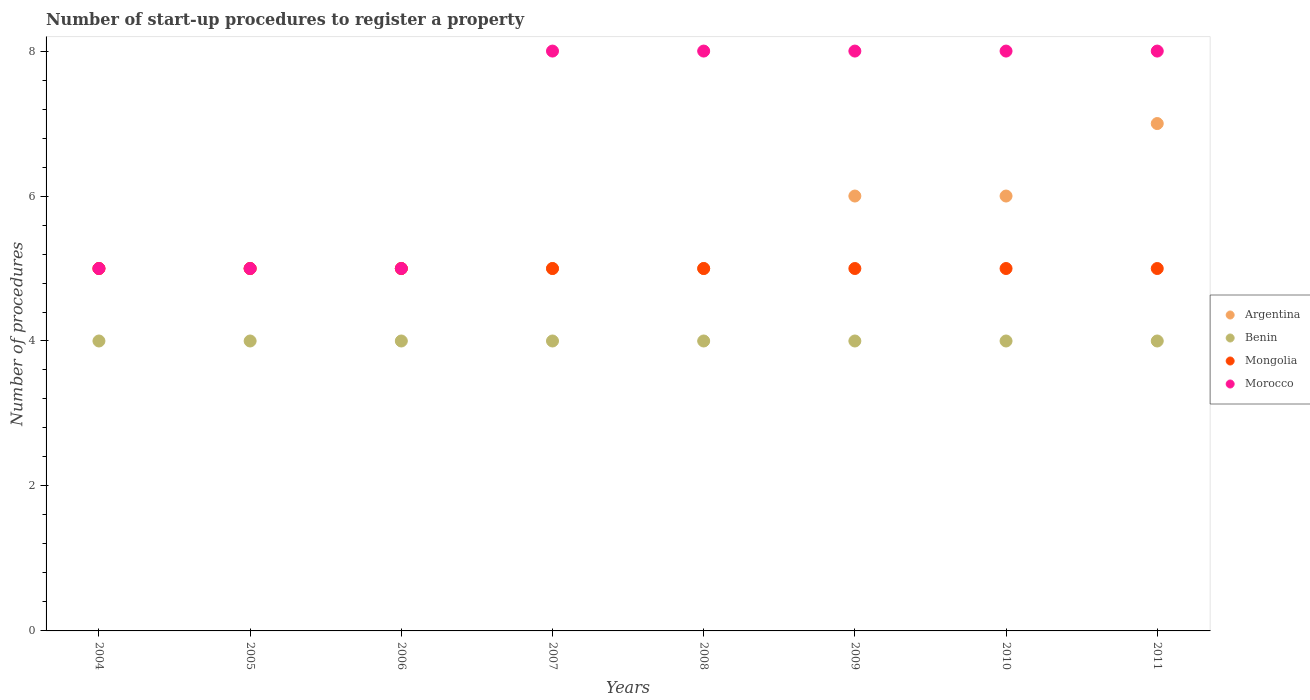Is the number of dotlines equal to the number of legend labels?
Offer a terse response. Yes. What is the number of procedures required to register a property in Morocco in 2006?
Offer a very short reply. 5. Across all years, what is the maximum number of procedures required to register a property in Benin?
Give a very brief answer. 4. Across all years, what is the minimum number of procedures required to register a property in Morocco?
Provide a short and direct response. 5. In which year was the number of procedures required to register a property in Morocco minimum?
Offer a very short reply. 2004. What is the total number of procedures required to register a property in Benin in the graph?
Ensure brevity in your answer.  32. What is the difference between the number of procedures required to register a property in Argentina in 2007 and that in 2009?
Your response must be concise. -1. What is the difference between the number of procedures required to register a property in Morocco in 2004 and the number of procedures required to register a property in Argentina in 2010?
Keep it short and to the point. -1. What is the average number of procedures required to register a property in Benin per year?
Offer a very short reply. 4. In the year 2007, what is the difference between the number of procedures required to register a property in Benin and number of procedures required to register a property in Argentina?
Offer a very short reply. -1. In how many years, is the number of procedures required to register a property in Argentina greater than 4.8?
Offer a terse response. 8. What is the ratio of the number of procedures required to register a property in Argentina in 2007 to that in 2010?
Give a very brief answer. 0.83. Is the number of procedures required to register a property in Mongolia in 2004 less than that in 2009?
Make the answer very short. No. In how many years, is the number of procedures required to register a property in Morocco greater than the average number of procedures required to register a property in Morocco taken over all years?
Keep it short and to the point. 5. Is the sum of the number of procedures required to register a property in Benin in 2009 and 2011 greater than the maximum number of procedures required to register a property in Argentina across all years?
Ensure brevity in your answer.  Yes. Is it the case that in every year, the sum of the number of procedures required to register a property in Morocco and number of procedures required to register a property in Argentina  is greater than the number of procedures required to register a property in Mongolia?
Ensure brevity in your answer.  Yes. Is the number of procedures required to register a property in Mongolia strictly less than the number of procedures required to register a property in Argentina over the years?
Provide a short and direct response. No. What is the difference between two consecutive major ticks on the Y-axis?
Your answer should be very brief. 2. Are the values on the major ticks of Y-axis written in scientific E-notation?
Ensure brevity in your answer.  No. Where does the legend appear in the graph?
Make the answer very short. Center right. What is the title of the graph?
Your answer should be compact. Number of start-up procedures to register a property. Does "Madagascar" appear as one of the legend labels in the graph?
Make the answer very short. No. What is the label or title of the Y-axis?
Keep it short and to the point. Number of procedures. What is the Number of procedures of Benin in 2004?
Your answer should be compact. 4. What is the Number of procedures of Benin in 2005?
Offer a very short reply. 4. What is the Number of procedures of Argentina in 2006?
Keep it short and to the point. 5. What is the Number of procedures in Benin in 2006?
Offer a very short reply. 4. What is the Number of procedures of Mongolia in 2006?
Provide a succinct answer. 5. What is the Number of procedures of Morocco in 2006?
Ensure brevity in your answer.  5. What is the Number of procedures of Mongolia in 2007?
Your response must be concise. 5. What is the Number of procedures of Mongolia in 2008?
Your answer should be very brief. 5. What is the Number of procedures in Benin in 2009?
Offer a very short reply. 4. What is the Number of procedures in Mongolia in 2009?
Your answer should be compact. 5. What is the Number of procedures of Morocco in 2009?
Offer a terse response. 8. What is the Number of procedures of Benin in 2010?
Your answer should be compact. 4. What is the Number of procedures in Benin in 2011?
Provide a succinct answer. 4. What is the Number of procedures in Mongolia in 2011?
Offer a terse response. 5. What is the Number of procedures of Morocco in 2011?
Offer a terse response. 8. Across all years, what is the maximum Number of procedures of Mongolia?
Your response must be concise. 5. Across all years, what is the maximum Number of procedures in Morocco?
Keep it short and to the point. 8. Across all years, what is the minimum Number of procedures in Benin?
Your answer should be very brief. 4. Across all years, what is the minimum Number of procedures in Mongolia?
Your response must be concise. 5. Across all years, what is the minimum Number of procedures in Morocco?
Keep it short and to the point. 5. What is the total Number of procedures of Benin in the graph?
Make the answer very short. 32. What is the difference between the Number of procedures of Argentina in 2004 and that in 2005?
Your response must be concise. 0. What is the difference between the Number of procedures in Benin in 2004 and that in 2007?
Your answer should be compact. 0. What is the difference between the Number of procedures in Mongolia in 2004 and that in 2007?
Offer a very short reply. 0. What is the difference between the Number of procedures of Morocco in 2004 and that in 2007?
Offer a terse response. -3. What is the difference between the Number of procedures of Argentina in 2004 and that in 2008?
Ensure brevity in your answer.  0. What is the difference between the Number of procedures in Mongolia in 2004 and that in 2008?
Make the answer very short. 0. What is the difference between the Number of procedures of Morocco in 2004 and that in 2008?
Your answer should be very brief. -3. What is the difference between the Number of procedures in Argentina in 2004 and that in 2009?
Your response must be concise. -1. What is the difference between the Number of procedures in Benin in 2004 and that in 2009?
Your response must be concise. 0. What is the difference between the Number of procedures in Mongolia in 2004 and that in 2010?
Your response must be concise. 0. What is the difference between the Number of procedures in Argentina in 2004 and that in 2011?
Your response must be concise. -2. What is the difference between the Number of procedures in Morocco in 2004 and that in 2011?
Make the answer very short. -3. What is the difference between the Number of procedures of Argentina in 2005 and that in 2006?
Provide a succinct answer. 0. What is the difference between the Number of procedures of Benin in 2005 and that in 2007?
Offer a terse response. 0. What is the difference between the Number of procedures of Morocco in 2005 and that in 2007?
Your response must be concise. -3. What is the difference between the Number of procedures in Argentina in 2005 and that in 2008?
Offer a very short reply. 0. What is the difference between the Number of procedures in Argentina in 2005 and that in 2009?
Your response must be concise. -1. What is the difference between the Number of procedures of Benin in 2005 and that in 2010?
Your response must be concise. 0. What is the difference between the Number of procedures in Mongolia in 2005 and that in 2010?
Keep it short and to the point. 0. What is the difference between the Number of procedures in Morocco in 2005 and that in 2010?
Your answer should be very brief. -3. What is the difference between the Number of procedures of Benin in 2005 and that in 2011?
Give a very brief answer. 0. What is the difference between the Number of procedures of Morocco in 2005 and that in 2011?
Make the answer very short. -3. What is the difference between the Number of procedures in Benin in 2006 and that in 2007?
Give a very brief answer. 0. What is the difference between the Number of procedures of Mongolia in 2006 and that in 2007?
Give a very brief answer. 0. What is the difference between the Number of procedures in Morocco in 2006 and that in 2007?
Offer a terse response. -3. What is the difference between the Number of procedures of Benin in 2006 and that in 2008?
Your answer should be compact. 0. What is the difference between the Number of procedures in Mongolia in 2006 and that in 2008?
Ensure brevity in your answer.  0. What is the difference between the Number of procedures of Morocco in 2006 and that in 2009?
Ensure brevity in your answer.  -3. What is the difference between the Number of procedures in Argentina in 2006 and that in 2010?
Provide a short and direct response. -1. What is the difference between the Number of procedures of Benin in 2006 and that in 2010?
Your answer should be compact. 0. What is the difference between the Number of procedures of Mongolia in 2006 and that in 2010?
Your answer should be compact. 0. What is the difference between the Number of procedures of Benin in 2006 and that in 2011?
Provide a succinct answer. 0. What is the difference between the Number of procedures of Mongolia in 2006 and that in 2011?
Offer a terse response. 0. What is the difference between the Number of procedures in Argentina in 2007 and that in 2008?
Provide a short and direct response. 0. What is the difference between the Number of procedures in Benin in 2007 and that in 2008?
Make the answer very short. 0. What is the difference between the Number of procedures of Benin in 2007 and that in 2009?
Your answer should be compact. 0. What is the difference between the Number of procedures of Mongolia in 2007 and that in 2009?
Offer a terse response. 0. What is the difference between the Number of procedures of Argentina in 2007 and that in 2010?
Your response must be concise. -1. What is the difference between the Number of procedures of Mongolia in 2007 and that in 2010?
Keep it short and to the point. 0. What is the difference between the Number of procedures of Morocco in 2007 and that in 2010?
Your answer should be compact. 0. What is the difference between the Number of procedures in Argentina in 2007 and that in 2011?
Offer a very short reply. -2. What is the difference between the Number of procedures in Benin in 2007 and that in 2011?
Provide a short and direct response. 0. What is the difference between the Number of procedures in Argentina in 2008 and that in 2009?
Provide a short and direct response. -1. What is the difference between the Number of procedures of Benin in 2008 and that in 2010?
Keep it short and to the point. 0. What is the difference between the Number of procedures of Mongolia in 2008 and that in 2010?
Ensure brevity in your answer.  0. What is the difference between the Number of procedures in Benin in 2008 and that in 2011?
Give a very brief answer. 0. What is the difference between the Number of procedures of Mongolia in 2008 and that in 2011?
Give a very brief answer. 0. What is the difference between the Number of procedures of Argentina in 2009 and that in 2010?
Your answer should be compact. 0. What is the difference between the Number of procedures in Morocco in 2009 and that in 2010?
Your answer should be very brief. 0. What is the difference between the Number of procedures in Argentina in 2009 and that in 2011?
Provide a short and direct response. -1. What is the difference between the Number of procedures of Mongolia in 2009 and that in 2011?
Ensure brevity in your answer.  0. What is the difference between the Number of procedures of Benin in 2010 and that in 2011?
Provide a short and direct response. 0. What is the difference between the Number of procedures in Mongolia in 2010 and that in 2011?
Your response must be concise. 0. What is the difference between the Number of procedures in Morocco in 2010 and that in 2011?
Your answer should be very brief. 0. What is the difference between the Number of procedures of Benin in 2004 and the Number of procedures of Mongolia in 2005?
Ensure brevity in your answer.  -1. What is the difference between the Number of procedures of Mongolia in 2004 and the Number of procedures of Morocco in 2005?
Your response must be concise. 0. What is the difference between the Number of procedures in Argentina in 2004 and the Number of procedures in Benin in 2006?
Provide a succinct answer. 1. What is the difference between the Number of procedures in Argentina in 2004 and the Number of procedures in Morocco in 2006?
Provide a succinct answer. 0. What is the difference between the Number of procedures in Mongolia in 2004 and the Number of procedures in Morocco in 2006?
Offer a very short reply. 0. What is the difference between the Number of procedures in Argentina in 2004 and the Number of procedures in Benin in 2007?
Give a very brief answer. 1. What is the difference between the Number of procedures in Argentina in 2004 and the Number of procedures in Morocco in 2007?
Provide a succinct answer. -3. What is the difference between the Number of procedures in Mongolia in 2004 and the Number of procedures in Morocco in 2007?
Your response must be concise. -3. What is the difference between the Number of procedures of Argentina in 2004 and the Number of procedures of Benin in 2008?
Offer a terse response. 1. What is the difference between the Number of procedures in Argentina in 2004 and the Number of procedures in Mongolia in 2008?
Your answer should be very brief. 0. What is the difference between the Number of procedures in Benin in 2004 and the Number of procedures in Mongolia in 2008?
Your answer should be very brief. -1. What is the difference between the Number of procedures in Mongolia in 2004 and the Number of procedures in Morocco in 2008?
Offer a terse response. -3. What is the difference between the Number of procedures in Argentina in 2004 and the Number of procedures in Benin in 2009?
Give a very brief answer. 1. What is the difference between the Number of procedures in Argentina in 2004 and the Number of procedures in Mongolia in 2009?
Keep it short and to the point. 0. What is the difference between the Number of procedures in Argentina in 2004 and the Number of procedures in Morocco in 2009?
Make the answer very short. -3. What is the difference between the Number of procedures in Benin in 2004 and the Number of procedures in Mongolia in 2009?
Give a very brief answer. -1. What is the difference between the Number of procedures of Benin in 2004 and the Number of procedures of Morocco in 2009?
Offer a very short reply. -4. What is the difference between the Number of procedures in Argentina in 2004 and the Number of procedures in Morocco in 2010?
Your answer should be compact. -3. What is the difference between the Number of procedures in Benin in 2004 and the Number of procedures in Mongolia in 2010?
Provide a short and direct response. -1. What is the difference between the Number of procedures in Argentina in 2004 and the Number of procedures in Benin in 2011?
Your answer should be compact. 1. What is the difference between the Number of procedures of Benin in 2004 and the Number of procedures of Morocco in 2011?
Offer a terse response. -4. What is the difference between the Number of procedures of Mongolia in 2004 and the Number of procedures of Morocco in 2011?
Keep it short and to the point. -3. What is the difference between the Number of procedures of Argentina in 2005 and the Number of procedures of Benin in 2006?
Give a very brief answer. 1. What is the difference between the Number of procedures of Argentina in 2005 and the Number of procedures of Morocco in 2006?
Give a very brief answer. 0. What is the difference between the Number of procedures of Benin in 2005 and the Number of procedures of Morocco in 2006?
Offer a very short reply. -1. What is the difference between the Number of procedures in Mongolia in 2005 and the Number of procedures in Morocco in 2006?
Give a very brief answer. 0. What is the difference between the Number of procedures of Argentina in 2005 and the Number of procedures of Benin in 2007?
Make the answer very short. 1. What is the difference between the Number of procedures of Benin in 2005 and the Number of procedures of Mongolia in 2007?
Give a very brief answer. -1. What is the difference between the Number of procedures in Benin in 2005 and the Number of procedures in Morocco in 2007?
Your response must be concise. -4. What is the difference between the Number of procedures of Mongolia in 2005 and the Number of procedures of Morocco in 2007?
Ensure brevity in your answer.  -3. What is the difference between the Number of procedures of Argentina in 2005 and the Number of procedures of Morocco in 2008?
Give a very brief answer. -3. What is the difference between the Number of procedures in Benin in 2005 and the Number of procedures in Morocco in 2008?
Provide a short and direct response. -4. What is the difference between the Number of procedures of Argentina in 2005 and the Number of procedures of Mongolia in 2009?
Make the answer very short. 0. What is the difference between the Number of procedures of Benin in 2005 and the Number of procedures of Mongolia in 2009?
Offer a very short reply. -1. What is the difference between the Number of procedures in Benin in 2005 and the Number of procedures in Morocco in 2009?
Provide a short and direct response. -4. What is the difference between the Number of procedures of Mongolia in 2005 and the Number of procedures of Morocco in 2009?
Your response must be concise. -3. What is the difference between the Number of procedures in Argentina in 2005 and the Number of procedures in Benin in 2010?
Provide a short and direct response. 1. What is the difference between the Number of procedures in Argentina in 2005 and the Number of procedures in Morocco in 2010?
Your answer should be compact. -3. What is the difference between the Number of procedures of Benin in 2005 and the Number of procedures of Mongolia in 2010?
Make the answer very short. -1. What is the difference between the Number of procedures in Argentina in 2005 and the Number of procedures in Benin in 2011?
Offer a terse response. 1. What is the difference between the Number of procedures in Argentina in 2005 and the Number of procedures in Mongolia in 2011?
Offer a very short reply. 0. What is the difference between the Number of procedures of Argentina in 2005 and the Number of procedures of Morocco in 2011?
Provide a short and direct response. -3. What is the difference between the Number of procedures of Benin in 2005 and the Number of procedures of Morocco in 2011?
Your answer should be very brief. -4. What is the difference between the Number of procedures of Argentina in 2006 and the Number of procedures of Benin in 2007?
Your answer should be compact. 1. What is the difference between the Number of procedures of Benin in 2006 and the Number of procedures of Morocco in 2007?
Keep it short and to the point. -4. What is the difference between the Number of procedures of Mongolia in 2006 and the Number of procedures of Morocco in 2007?
Offer a very short reply. -3. What is the difference between the Number of procedures in Argentina in 2006 and the Number of procedures in Mongolia in 2008?
Offer a terse response. 0. What is the difference between the Number of procedures in Benin in 2006 and the Number of procedures in Mongolia in 2008?
Provide a short and direct response. -1. What is the difference between the Number of procedures in Mongolia in 2006 and the Number of procedures in Morocco in 2008?
Offer a very short reply. -3. What is the difference between the Number of procedures in Argentina in 2006 and the Number of procedures in Benin in 2009?
Provide a short and direct response. 1. What is the difference between the Number of procedures in Argentina in 2006 and the Number of procedures in Mongolia in 2009?
Keep it short and to the point. 0. What is the difference between the Number of procedures of Benin in 2006 and the Number of procedures of Mongolia in 2009?
Give a very brief answer. -1. What is the difference between the Number of procedures in Mongolia in 2006 and the Number of procedures in Morocco in 2009?
Keep it short and to the point. -3. What is the difference between the Number of procedures of Argentina in 2006 and the Number of procedures of Mongolia in 2010?
Provide a succinct answer. 0. What is the difference between the Number of procedures in Argentina in 2006 and the Number of procedures in Morocco in 2010?
Your answer should be compact. -3. What is the difference between the Number of procedures of Benin in 2006 and the Number of procedures of Mongolia in 2010?
Ensure brevity in your answer.  -1. What is the difference between the Number of procedures of Benin in 2006 and the Number of procedures of Morocco in 2010?
Offer a very short reply. -4. What is the difference between the Number of procedures of Argentina in 2006 and the Number of procedures of Benin in 2011?
Offer a very short reply. 1. What is the difference between the Number of procedures in Argentina in 2006 and the Number of procedures in Mongolia in 2011?
Keep it short and to the point. 0. What is the difference between the Number of procedures of Benin in 2006 and the Number of procedures of Mongolia in 2011?
Give a very brief answer. -1. What is the difference between the Number of procedures in Benin in 2006 and the Number of procedures in Morocco in 2011?
Keep it short and to the point. -4. What is the difference between the Number of procedures in Argentina in 2007 and the Number of procedures in Morocco in 2008?
Provide a short and direct response. -3. What is the difference between the Number of procedures of Benin in 2007 and the Number of procedures of Mongolia in 2008?
Make the answer very short. -1. What is the difference between the Number of procedures in Benin in 2007 and the Number of procedures in Morocco in 2008?
Your answer should be very brief. -4. What is the difference between the Number of procedures in Mongolia in 2007 and the Number of procedures in Morocco in 2008?
Make the answer very short. -3. What is the difference between the Number of procedures in Argentina in 2007 and the Number of procedures in Mongolia in 2009?
Make the answer very short. 0. What is the difference between the Number of procedures in Benin in 2007 and the Number of procedures in Mongolia in 2009?
Offer a terse response. -1. What is the difference between the Number of procedures in Benin in 2007 and the Number of procedures in Morocco in 2009?
Offer a very short reply. -4. What is the difference between the Number of procedures in Mongolia in 2007 and the Number of procedures in Morocco in 2009?
Your response must be concise. -3. What is the difference between the Number of procedures of Argentina in 2007 and the Number of procedures of Benin in 2010?
Offer a terse response. 1. What is the difference between the Number of procedures of Argentina in 2007 and the Number of procedures of Mongolia in 2010?
Give a very brief answer. 0. What is the difference between the Number of procedures in Argentina in 2007 and the Number of procedures in Morocco in 2010?
Provide a succinct answer. -3. What is the difference between the Number of procedures in Benin in 2007 and the Number of procedures in Mongolia in 2010?
Offer a terse response. -1. What is the difference between the Number of procedures of Mongolia in 2007 and the Number of procedures of Morocco in 2010?
Your response must be concise. -3. What is the difference between the Number of procedures of Argentina in 2007 and the Number of procedures of Mongolia in 2011?
Keep it short and to the point. 0. What is the difference between the Number of procedures in Argentina in 2007 and the Number of procedures in Morocco in 2011?
Your response must be concise. -3. What is the difference between the Number of procedures of Mongolia in 2007 and the Number of procedures of Morocco in 2011?
Make the answer very short. -3. What is the difference between the Number of procedures of Argentina in 2008 and the Number of procedures of Morocco in 2009?
Offer a terse response. -3. What is the difference between the Number of procedures in Argentina in 2008 and the Number of procedures in Mongolia in 2010?
Provide a short and direct response. 0. What is the difference between the Number of procedures of Argentina in 2008 and the Number of procedures of Morocco in 2010?
Your answer should be compact. -3. What is the difference between the Number of procedures in Benin in 2008 and the Number of procedures in Mongolia in 2010?
Your response must be concise. -1. What is the difference between the Number of procedures in Benin in 2008 and the Number of procedures in Morocco in 2010?
Provide a short and direct response. -4. What is the difference between the Number of procedures of Mongolia in 2008 and the Number of procedures of Morocco in 2010?
Make the answer very short. -3. What is the difference between the Number of procedures of Benin in 2008 and the Number of procedures of Mongolia in 2011?
Your response must be concise. -1. What is the difference between the Number of procedures of Mongolia in 2008 and the Number of procedures of Morocco in 2011?
Give a very brief answer. -3. What is the difference between the Number of procedures of Benin in 2009 and the Number of procedures of Mongolia in 2010?
Your response must be concise. -1. What is the difference between the Number of procedures in Mongolia in 2009 and the Number of procedures in Morocco in 2010?
Provide a succinct answer. -3. What is the difference between the Number of procedures of Argentina in 2009 and the Number of procedures of Mongolia in 2011?
Ensure brevity in your answer.  1. What is the difference between the Number of procedures in Benin in 2009 and the Number of procedures in Mongolia in 2011?
Offer a very short reply. -1. What is the difference between the Number of procedures in Benin in 2009 and the Number of procedures in Morocco in 2011?
Your response must be concise. -4. What is the difference between the Number of procedures of Argentina in 2010 and the Number of procedures of Benin in 2011?
Provide a succinct answer. 2. What is the difference between the Number of procedures in Argentina in 2010 and the Number of procedures in Morocco in 2011?
Offer a terse response. -2. What is the difference between the Number of procedures in Benin in 2010 and the Number of procedures in Morocco in 2011?
Give a very brief answer. -4. What is the difference between the Number of procedures of Mongolia in 2010 and the Number of procedures of Morocco in 2011?
Your answer should be very brief. -3. What is the average Number of procedures of Morocco per year?
Your answer should be compact. 6.88. In the year 2004, what is the difference between the Number of procedures of Argentina and Number of procedures of Mongolia?
Your answer should be very brief. 0. In the year 2004, what is the difference between the Number of procedures of Argentina and Number of procedures of Morocco?
Make the answer very short. 0. In the year 2004, what is the difference between the Number of procedures of Benin and Number of procedures of Mongolia?
Your answer should be compact. -1. In the year 2004, what is the difference between the Number of procedures in Mongolia and Number of procedures in Morocco?
Your answer should be compact. 0. In the year 2005, what is the difference between the Number of procedures in Argentina and Number of procedures in Benin?
Your response must be concise. 1. In the year 2005, what is the difference between the Number of procedures of Argentina and Number of procedures of Mongolia?
Keep it short and to the point. 0. In the year 2005, what is the difference between the Number of procedures of Benin and Number of procedures of Mongolia?
Make the answer very short. -1. In the year 2005, what is the difference between the Number of procedures of Benin and Number of procedures of Morocco?
Offer a terse response. -1. In the year 2005, what is the difference between the Number of procedures in Mongolia and Number of procedures in Morocco?
Offer a terse response. 0. In the year 2006, what is the difference between the Number of procedures of Benin and Number of procedures of Morocco?
Make the answer very short. -1. In the year 2006, what is the difference between the Number of procedures of Mongolia and Number of procedures of Morocco?
Your answer should be compact. 0. In the year 2007, what is the difference between the Number of procedures of Argentina and Number of procedures of Benin?
Your response must be concise. 1. In the year 2007, what is the difference between the Number of procedures in Argentina and Number of procedures in Mongolia?
Make the answer very short. 0. In the year 2007, what is the difference between the Number of procedures of Argentina and Number of procedures of Morocco?
Your answer should be compact. -3. In the year 2007, what is the difference between the Number of procedures of Benin and Number of procedures of Mongolia?
Offer a terse response. -1. In the year 2007, what is the difference between the Number of procedures in Benin and Number of procedures in Morocco?
Your response must be concise. -4. In the year 2007, what is the difference between the Number of procedures in Mongolia and Number of procedures in Morocco?
Provide a succinct answer. -3. In the year 2008, what is the difference between the Number of procedures of Argentina and Number of procedures of Benin?
Your response must be concise. 1. In the year 2008, what is the difference between the Number of procedures of Argentina and Number of procedures of Morocco?
Make the answer very short. -3. In the year 2008, what is the difference between the Number of procedures of Benin and Number of procedures of Morocco?
Give a very brief answer. -4. In the year 2008, what is the difference between the Number of procedures of Mongolia and Number of procedures of Morocco?
Offer a terse response. -3. In the year 2009, what is the difference between the Number of procedures in Argentina and Number of procedures in Mongolia?
Your answer should be very brief. 1. In the year 2009, what is the difference between the Number of procedures in Argentina and Number of procedures in Morocco?
Offer a terse response. -2. In the year 2010, what is the difference between the Number of procedures of Argentina and Number of procedures of Mongolia?
Make the answer very short. 1. In the year 2010, what is the difference between the Number of procedures in Argentina and Number of procedures in Morocco?
Your answer should be very brief. -2. In the year 2010, what is the difference between the Number of procedures in Benin and Number of procedures in Mongolia?
Your answer should be compact. -1. In the year 2010, what is the difference between the Number of procedures of Benin and Number of procedures of Morocco?
Offer a very short reply. -4. In the year 2011, what is the difference between the Number of procedures in Argentina and Number of procedures in Mongolia?
Make the answer very short. 2. In the year 2011, what is the difference between the Number of procedures of Benin and Number of procedures of Morocco?
Your answer should be very brief. -4. In the year 2011, what is the difference between the Number of procedures in Mongolia and Number of procedures in Morocco?
Provide a succinct answer. -3. What is the ratio of the Number of procedures in Benin in 2004 to that in 2005?
Your answer should be compact. 1. What is the ratio of the Number of procedures of Morocco in 2004 to that in 2005?
Offer a very short reply. 1. What is the ratio of the Number of procedures in Argentina in 2004 to that in 2006?
Give a very brief answer. 1. What is the ratio of the Number of procedures of Mongolia in 2004 to that in 2006?
Provide a succinct answer. 1. What is the ratio of the Number of procedures in Morocco in 2004 to that in 2006?
Your answer should be very brief. 1. What is the ratio of the Number of procedures of Mongolia in 2004 to that in 2007?
Make the answer very short. 1. What is the ratio of the Number of procedures of Morocco in 2004 to that in 2007?
Your answer should be very brief. 0.62. What is the ratio of the Number of procedures in Argentina in 2004 to that in 2008?
Your answer should be compact. 1. What is the ratio of the Number of procedures of Benin in 2004 to that in 2008?
Your answer should be very brief. 1. What is the ratio of the Number of procedures of Mongolia in 2004 to that in 2008?
Make the answer very short. 1. What is the ratio of the Number of procedures in Morocco in 2004 to that in 2008?
Provide a short and direct response. 0.62. What is the ratio of the Number of procedures in Argentina in 2004 to that in 2009?
Give a very brief answer. 0.83. What is the ratio of the Number of procedures of Mongolia in 2004 to that in 2009?
Provide a succinct answer. 1. What is the ratio of the Number of procedures of Morocco in 2004 to that in 2009?
Make the answer very short. 0.62. What is the ratio of the Number of procedures of Morocco in 2004 to that in 2010?
Offer a very short reply. 0.62. What is the ratio of the Number of procedures in Argentina in 2004 to that in 2011?
Offer a terse response. 0.71. What is the ratio of the Number of procedures in Benin in 2004 to that in 2011?
Provide a short and direct response. 1. What is the ratio of the Number of procedures in Argentina in 2005 to that in 2006?
Offer a terse response. 1. What is the ratio of the Number of procedures in Benin in 2005 to that in 2006?
Make the answer very short. 1. What is the ratio of the Number of procedures in Morocco in 2005 to that in 2006?
Keep it short and to the point. 1. What is the ratio of the Number of procedures of Mongolia in 2005 to that in 2007?
Your answer should be compact. 1. What is the ratio of the Number of procedures in Morocco in 2005 to that in 2007?
Your response must be concise. 0.62. What is the ratio of the Number of procedures of Benin in 2005 to that in 2008?
Give a very brief answer. 1. What is the ratio of the Number of procedures in Mongolia in 2005 to that in 2008?
Make the answer very short. 1. What is the ratio of the Number of procedures of Morocco in 2005 to that in 2008?
Make the answer very short. 0.62. What is the ratio of the Number of procedures of Benin in 2005 to that in 2010?
Your answer should be compact. 1. What is the ratio of the Number of procedures in Mongolia in 2005 to that in 2010?
Offer a very short reply. 1. What is the ratio of the Number of procedures of Argentina in 2005 to that in 2011?
Provide a succinct answer. 0.71. What is the ratio of the Number of procedures in Benin in 2005 to that in 2011?
Offer a very short reply. 1. What is the ratio of the Number of procedures of Mongolia in 2005 to that in 2011?
Offer a very short reply. 1. What is the ratio of the Number of procedures of Mongolia in 2006 to that in 2007?
Ensure brevity in your answer.  1. What is the ratio of the Number of procedures of Morocco in 2006 to that in 2007?
Offer a very short reply. 0.62. What is the ratio of the Number of procedures in Mongolia in 2006 to that in 2008?
Provide a short and direct response. 1. What is the ratio of the Number of procedures of Morocco in 2006 to that in 2009?
Provide a succinct answer. 0.62. What is the ratio of the Number of procedures of Benin in 2006 to that in 2010?
Make the answer very short. 1. What is the ratio of the Number of procedures of Mongolia in 2006 to that in 2010?
Give a very brief answer. 1. What is the ratio of the Number of procedures of Argentina in 2006 to that in 2011?
Provide a succinct answer. 0.71. What is the ratio of the Number of procedures in Morocco in 2006 to that in 2011?
Keep it short and to the point. 0.62. What is the ratio of the Number of procedures of Argentina in 2007 to that in 2008?
Provide a succinct answer. 1. What is the ratio of the Number of procedures of Benin in 2007 to that in 2008?
Your answer should be very brief. 1. What is the ratio of the Number of procedures in Morocco in 2007 to that in 2008?
Make the answer very short. 1. What is the ratio of the Number of procedures in Argentina in 2007 to that in 2009?
Your response must be concise. 0.83. What is the ratio of the Number of procedures of Argentina in 2007 to that in 2010?
Provide a succinct answer. 0.83. What is the ratio of the Number of procedures of Mongolia in 2007 to that in 2010?
Ensure brevity in your answer.  1. What is the ratio of the Number of procedures in Argentina in 2007 to that in 2011?
Make the answer very short. 0.71. What is the ratio of the Number of procedures of Benin in 2007 to that in 2011?
Your answer should be compact. 1. What is the ratio of the Number of procedures in Morocco in 2007 to that in 2011?
Make the answer very short. 1. What is the ratio of the Number of procedures in Morocco in 2008 to that in 2009?
Provide a succinct answer. 1. What is the ratio of the Number of procedures of Benin in 2008 to that in 2010?
Your answer should be very brief. 1. What is the ratio of the Number of procedures in Argentina in 2008 to that in 2011?
Provide a succinct answer. 0.71. What is the ratio of the Number of procedures of Mongolia in 2008 to that in 2011?
Your answer should be compact. 1. What is the ratio of the Number of procedures of Morocco in 2008 to that in 2011?
Your answer should be compact. 1. What is the ratio of the Number of procedures of Argentina in 2009 to that in 2010?
Keep it short and to the point. 1. What is the ratio of the Number of procedures in Mongolia in 2009 to that in 2010?
Keep it short and to the point. 1. What is the ratio of the Number of procedures of Argentina in 2009 to that in 2011?
Keep it short and to the point. 0.86. What is the ratio of the Number of procedures of Benin in 2009 to that in 2011?
Your answer should be very brief. 1. What is the ratio of the Number of procedures of Mongolia in 2009 to that in 2011?
Your answer should be compact. 1. What is the ratio of the Number of procedures of Morocco in 2009 to that in 2011?
Your response must be concise. 1. What is the ratio of the Number of procedures of Argentina in 2010 to that in 2011?
Provide a succinct answer. 0.86. What is the difference between the highest and the second highest Number of procedures in Argentina?
Provide a short and direct response. 1. What is the difference between the highest and the lowest Number of procedures of Argentina?
Your answer should be very brief. 2. 